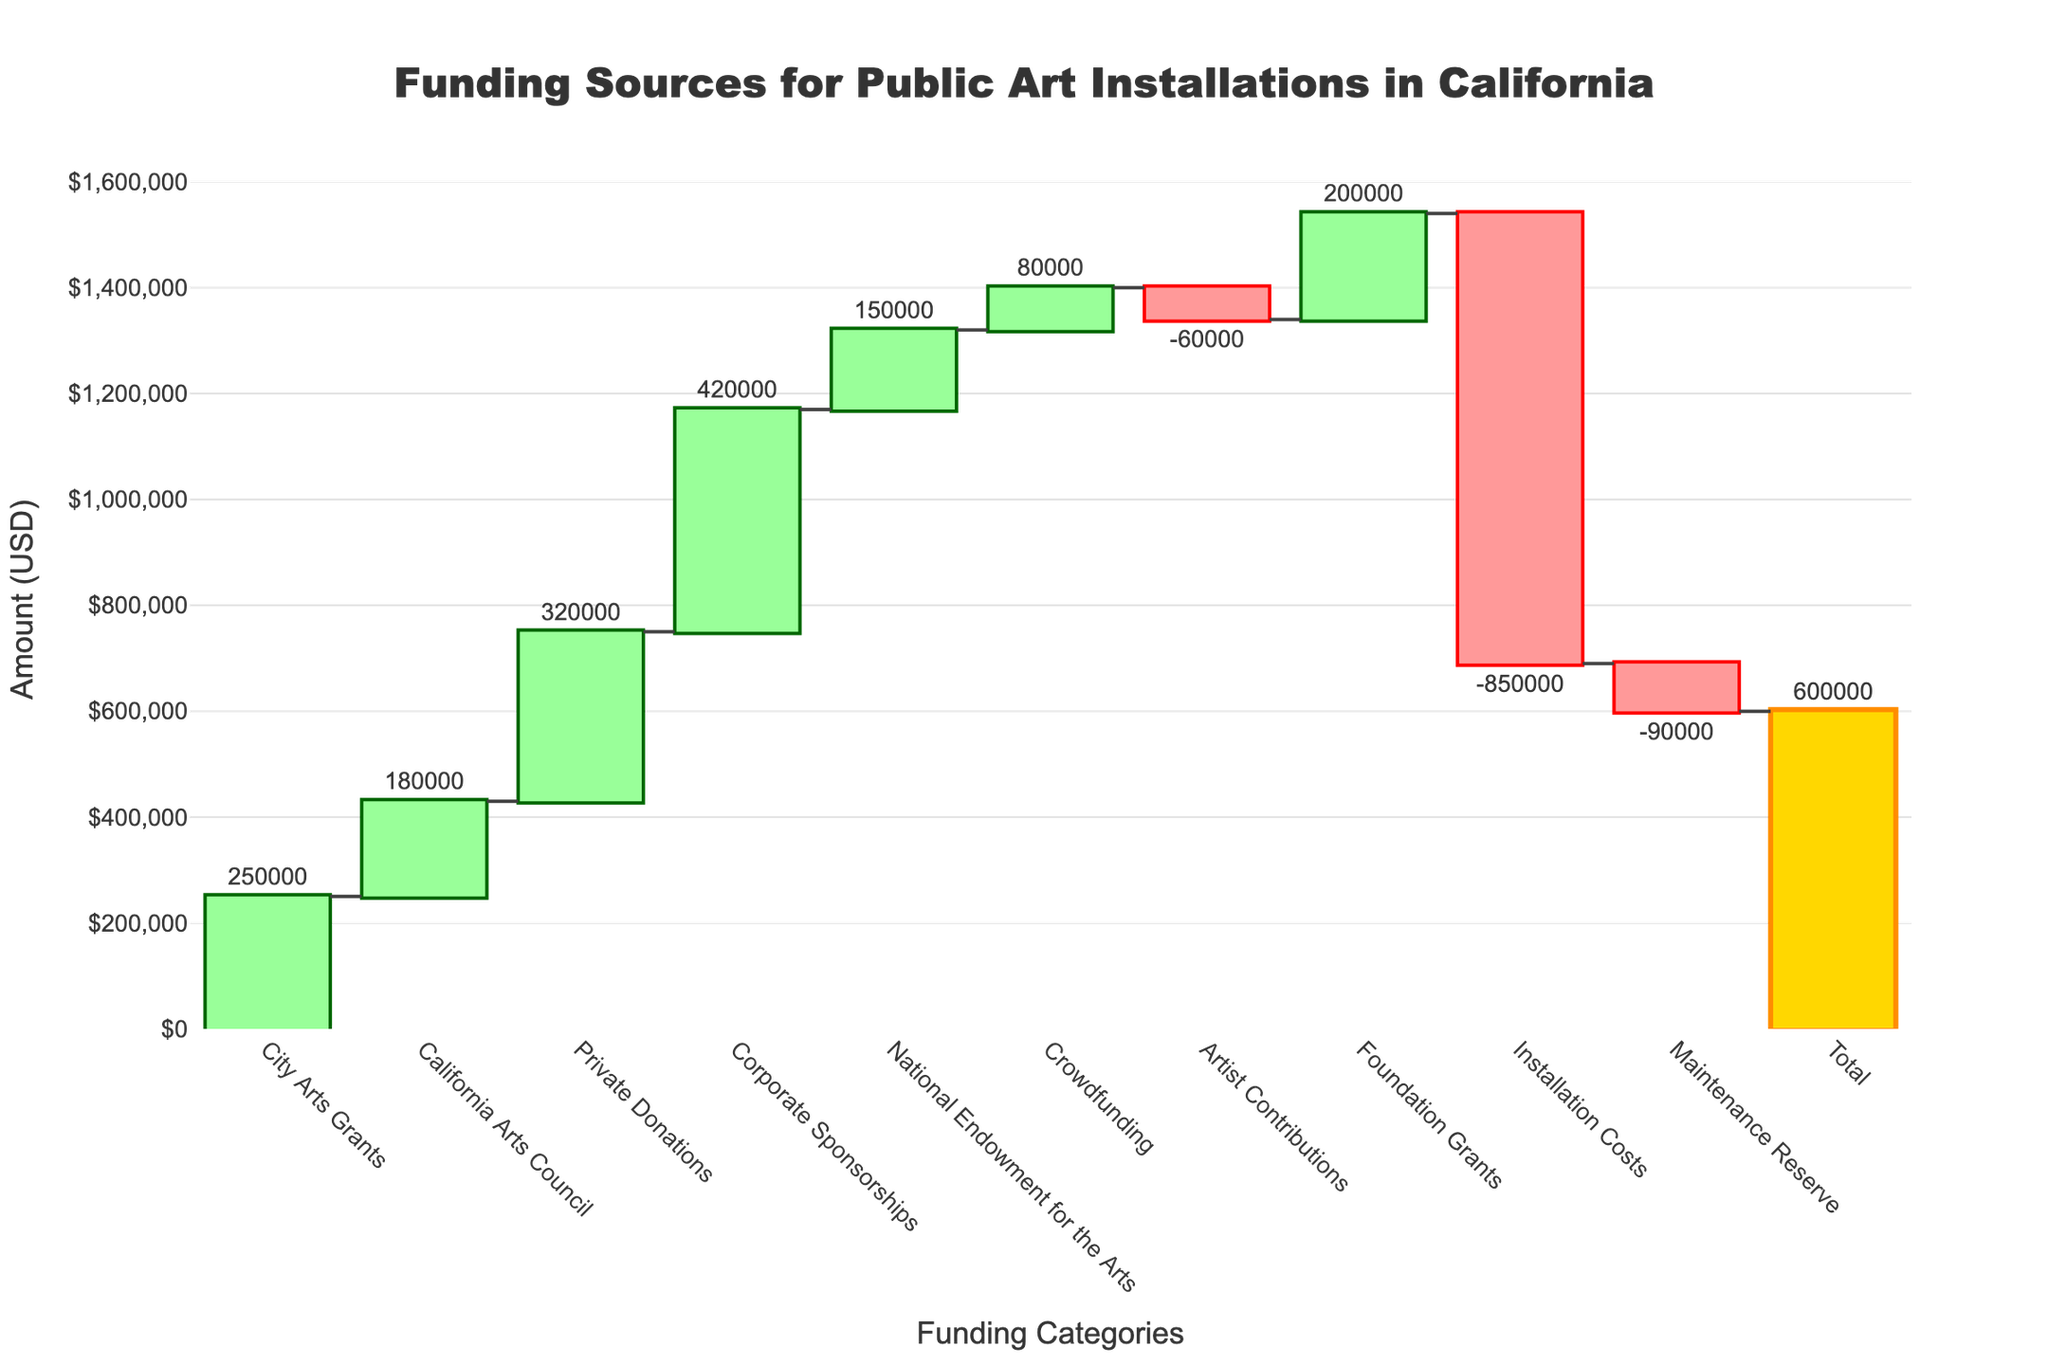What's the total amount of funding for public art installations in California? The total amount of funding is displayed at the end of the waterfall chart, summing up all the individual contributions and deductions.
Answer: 600,000 USD Which category contributes the most to the funding? By observing the height of the bars, Corporate Sponsorships is the tallest, indicating it contributes the most.
Answer: Corporate Sponsorships How much do private donations contribute to the funding? Private Donations have a specific bar associated with it on the chart and the labeled amount is 320,000 USD.
Answer: 320,000 USD What are the two categories that deduct the most from the funding, and what are their values? The largest deductions can be identified by observing the bars that extend downwards the most: Installation Costs and Maintenance Reserve, with values of -850,000 and -90,000 respectively.
Answer: Installation Costs: -850,000 USD, Maintenance Reserve: -90,000 USD How much does the National Endowment for the Arts contribute when compared to City Arts Grants? National Endowment for the Arts is 150,000 USD and City Arts Grants is 250,000 USD. The difference is 250,000 - 150,000.
Answer: 100,000 USD less What is the cumulative positive funding before any deductions? Sum all positive values: City Arts Grants (250,000), California Arts Council (180,000), Private Donations (320,000), Corporate Sponsorships (420,000), National Endowment for the Arts (150,000), Crowdfunding (80,000), Foundation Grants (200,000).
Answer: 1,600,000 USD What's the net effect of artist contributions on the total funding? Artist Contributions is a negative value: -60,000 USD. This indicates a deduction from the total funding.
Answer: -60,000 USD Is the total funding more or less than the sum of Installation Costs and Maintenance Reserve? Add the two largest deductions: -850,000 (Installation Costs) + -90,000 (Maintenance Reserve) = -940,000. The total funding is 600,000 USD which is more.
Answer: More What is the effect of crowdfunding on the total funding? Crowdfunding adds 80,000 USD to the total funding effort.
Answer: +80,000 USD How do the contributions of Crowdfunding and Foundation Grants compare? Crowdfunding contributes 80,000 USD while Foundation Grants contribute 200,000 USD. By subtraction, Foundation Grants contribute 120,000 USD more.
Answer: Foundation Grants contribute 120,000 USD more 